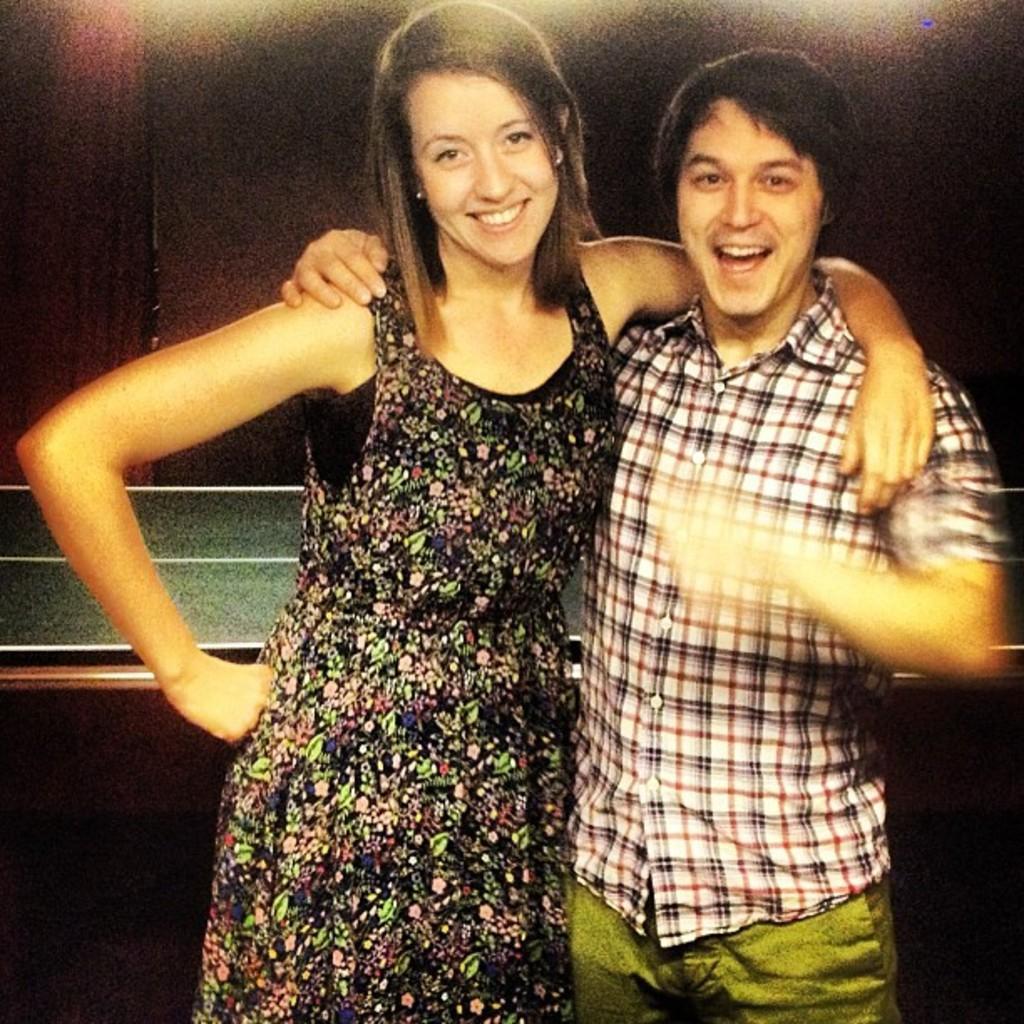How would you summarize this image in a sentence or two? There are two persons standing as we can see in the middle of this image, and there is a wall in the background. 